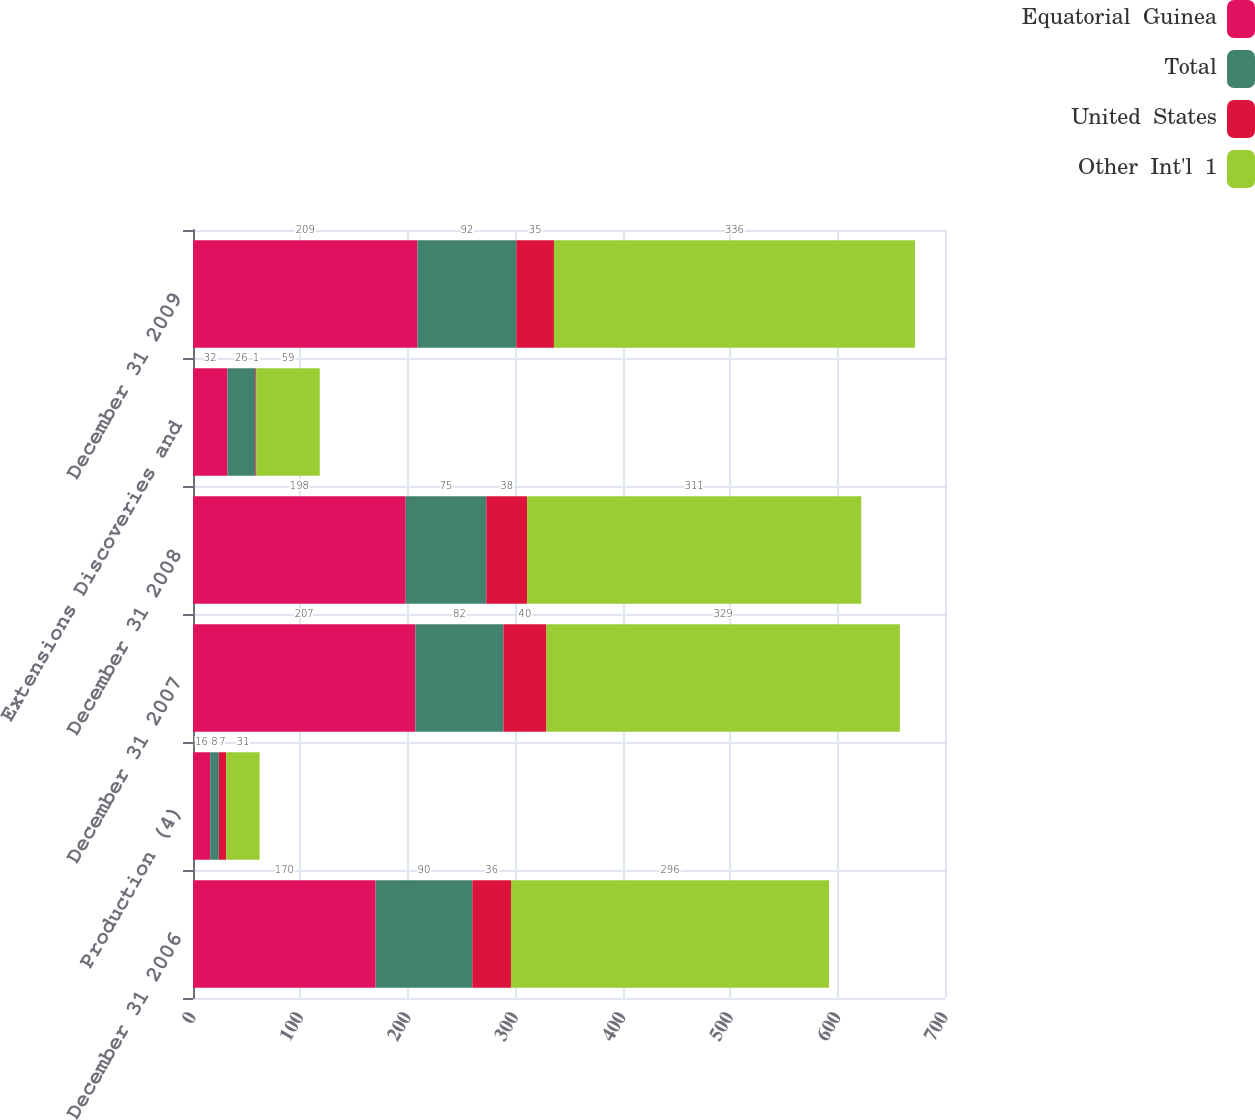Convert chart to OTSL. <chart><loc_0><loc_0><loc_500><loc_500><stacked_bar_chart><ecel><fcel>December 31 2006<fcel>Production (4)<fcel>December 31 2007<fcel>December 31 2008<fcel>Extensions Discoveries and<fcel>December 31 2009<nl><fcel>Equatorial  Guinea<fcel>170<fcel>16<fcel>207<fcel>198<fcel>32<fcel>209<nl><fcel>Total<fcel>90<fcel>8<fcel>82<fcel>75<fcel>26<fcel>92<nl><fcel>United  States<fcel>36<fcel>7<fcel>40<fcel>38<fcel>1<fcel>35<nl><fcel>Other  Int'l  1<fcel>296<fcel>31<fcel>329<fcel>311<fcel>59<fcel>336<nl></chart> 